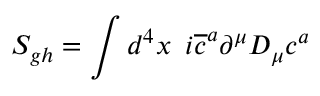<formula> <loc_0><loc_0><loc_500><loc_500>S _ { g h } = \int d ^ { 4 } x \, i \overline { c } ^ { a } \partial ^ { \mu } D _ { \mu } c ^ { a }</formula> 